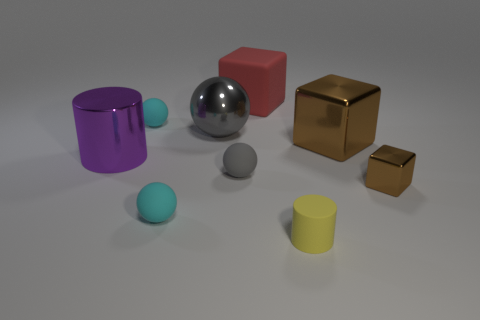Add 1 matte balls. How many objects exist? 10 Subtract all blocks. How many objects are left? 6 Add 5 large brown balls. How many large brown balls exist? 5 Subtract 0 green cylinders. How many objects are left? 9 Subtract all large shiny blocks. Subtract all tiny shiny blocks. How many objects are left? 7 Add 8 red rubber things. How many red rubber things are left? 9 